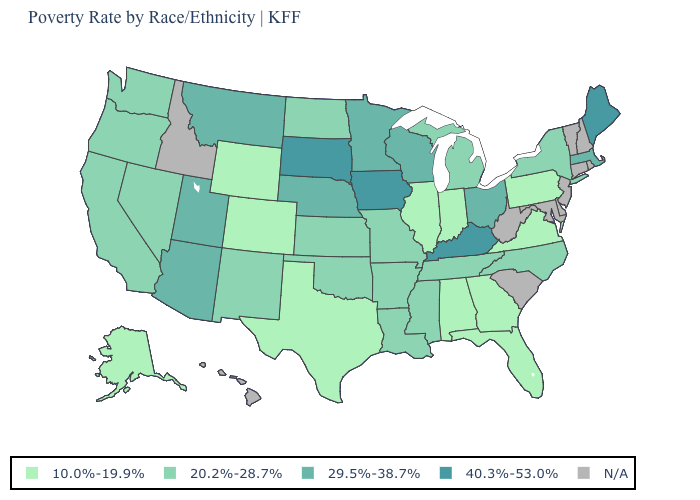Does the first symbol in the legend represent the smallest category?
Write a very short answer. Yes. Does Colorado have the lowest value in the USA?
Concise answer only. Yes. What is the value of Ohio?
Give a very brief answer. 29.5%-38.7%. What is the value of Alabama?
Answer briefly. 10.0%-19.9%. What is the value of Kentucky?
Concise answer only. 40.3%-53.0%. Does Minnesota have the lowest value in the USA?
Answer briefly. No. What is the value of Wyoming?
Concise answer only. 10.0%-19.9%. What is the lowest value in states that border Virginia?
Short answer required. 20.2%-28.7%. Does Arizona have the highest value in the West?
Short answer required. Yes. What is the value of Kentucky?
Short answer required. 40.3%-53.0%. What is the value of South Dakota?
Quick response, please. 40.3%-53.0%. Does the map have missing data?
Concise answer only. Yes. Is the legend a continuous bar?
Answer briefly. No. Does the first symbol in the legend represent the smallest category?
Keep it brief. Yes. 